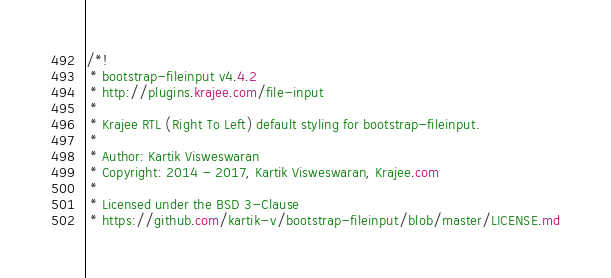<code> <loc_0><loc_0><loc_500><loc_500><_CSS_>/*!
 * bootstrap-fileinput v4.4.2
 * http://plugins.krajee.com/file-input
 *
 * Krajee RTL (Right To Left) default styling for bootstrap-fileinput.
 *
 * Author: Kartik Visweswaran
 * Copyright: 2014 - 2017, Kartik Visweswaran, Krajee.com
 *
 * Licensed under the BSD 3-Clause
 * https://github.com/kartik-v/bootstrap-fileinput/blob/master/LICENSE.md</code> 